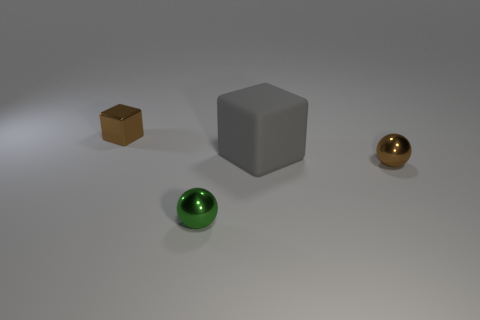Add 3 matte cubes. How many objects exist? 7 Add 2 tiny green shiny objects. How many tiny green shiny objects are left? 3 Add 3 large gray cubes. How many large gray cubes exist? 4 Subtract 0 blue cylinders. How many objects are left? 4 Subtract all tiny brown shiny cubes. Subtract all small cubes. How many objects are left? 2 